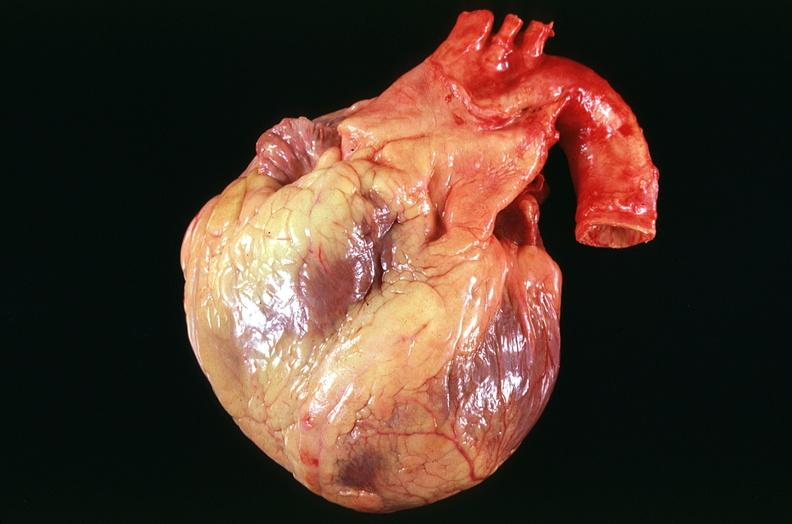does lesion of myocytolysis show congestive heart failure, three vessel coronary artery disease?
Answer the question using a single word or phrase. No 